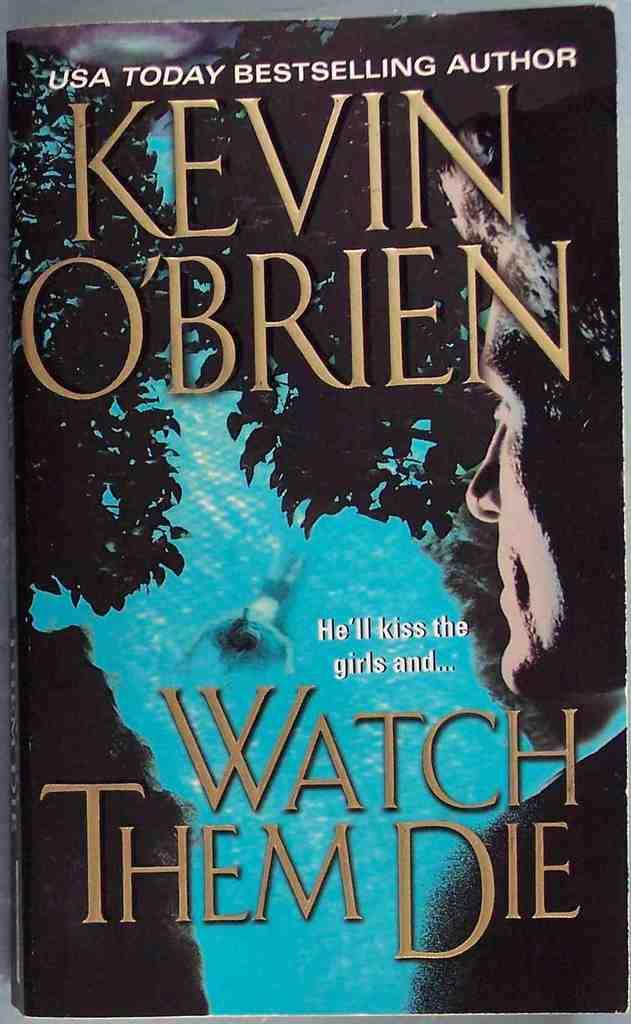<image>
Give a short and clear explanation of the subsequent image. A book with a person swimming on the cover by Kevin O'Brien. 